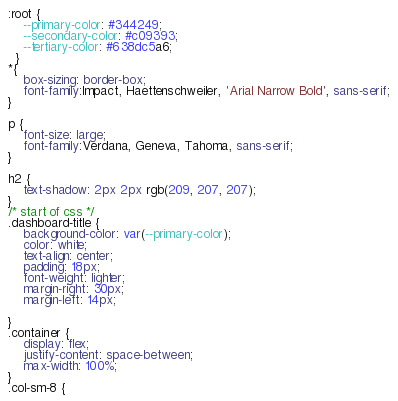Convert code to text. <code><loc_0><loc_0><loc_500><loc_500><_CSS_>:root {
    --primary-color: #344249;
    --secondary-color: #c09393;
    --tertiary-color: #638dc5a6;
  }
*{
    box-sizing: border-box;
    font-family:Impact, Haettenschweiler, 'Arial Narrow Bold', sans-serif;
}

p {
    font-size: large;
    font-family:Verdana, Geneva, Tahoma, sans-serif;
}

h2 {
    text-shadow: 2px 2px rgb(209, 207, 207);
}
/* start of css */
.dashboard-title {
    background-color: var(--primary-color);
    color: white;
    text-align: center;
    padding: 18px;
    font-weight: lighter;
    margin-right: 30px;
    margin-left: 14px;

}
.container {
    display: flex;
    justify-content: space-between;
    max-width: 100%;
}
.col-sm-8 {</code> 